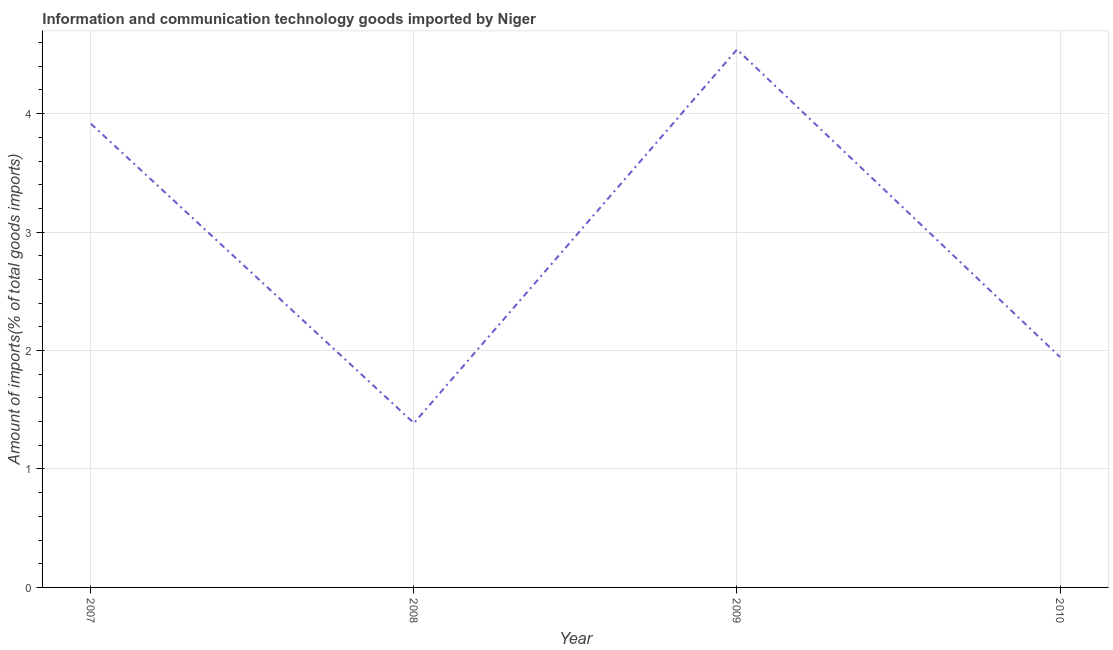What is the amount of ict goods imports in 2010?
Ensure brevity in your answer.  1.95. Across all years, what is the maximum amount of ict goods imports?
Your answer should be very brief. 4.54. Across all years, what is the minimum amount of ict goods imports?
Provide a short and direct response. 1.39. What is the sum of the amount of ict goods imports?
Provide a succinct answer. 11.79. What is the difference between the amount of ict goods imports in 2007 and 2008?
Make the answer very short. 2.53. What is the average amount of ict goods imports per year?
Your answer should be compact. 2.95. What is the median amount of ict goods imports?
Offer a terse response. 2.93. What is the ratio of the amount of ict goods imports in 2007 to that in 2008?
Give a very brief answer. 2.82. Is the amount of ict goods imports in 2007 less than that in 2008?
Ensure brevity in your answer.  No. Is the difference between the amount of ict goods imports in 2007 and 2010 greater than the difference between any two years?
Your response must be concise. No. What is the difference between the highest and the second highest amount of ict goods imports?
Offer a terse response. 0.63. Is the sum of the amount of ict goods imports in 2007 and 2008 greater than the maximum amount of ict goods imports across all years?
Offer a terse response. Yes. What is the difference between the highest and the lowest amount of ict goods imports?
Give a very brief answer. 3.15. In how many years, is the amount of ict goods imports greater than the average amount of ict goods imports taken over all years?
Your answer should be very brief. 2. Does the graph contain grids?
Your answer should be very brief. Yes. What is the title of the graph?
Your answer should be very brief. Information and communication technology goods imported by Niger. What is the label or title of the X-axis?
Your response must be concise. Year. What is the label or title of the Y-axis?
Provide a succinct answer. Amount of imports(% of total goods imports). What is the Amount of imports(% of total goods imports) in 2007?
Your answer should be very brief. 3.91. What is the Amount of imports(% of total goods imports) in 2008?
Offer a very short reply. 1.39. What is the Amount of imports(% of total goods imports) in 2009?
Offer a terse response. 4.54. What is the Amount of imports(% of total goods imports) of 2010?
Offer a terse response. 1.95. What is the difference between the Amount of imports(% of total goods imports) in 2007 and 2008?
Give a very brief answer. 2.53. What is the difference between the Amount of imports(% of total goods imports) in 2007 and 2009?
Ensure brevity in your answer.  -0.63. What is the difference between the Amount of imports(% of total goods imports) in 2007 and 2010?
Give a very brief answer. 1.97. What is the difference between the Amount of imports(% of total goods imports) in 2008 and 2009?
Your answer should be compact. -3.15. What is the difference between the Amount of imports(% of total goods imports) in 2008 and 2010?
Provide a succinct answer. -0.56. What is the difference between the Amount of imports(% of total goods imports) in 2009 and 2010?
Your response must be concise. 2.6. What is the ratio of the Amount of imports(% of total goods imports) in 2007 to that in 2008?
Ensure brevity in your answer.  2.82. What is the ratio of the Amount of imports(% of total goods imports) in 2007 to that in 2009?
Provide a succinct answer. 0.86. What is the ratio of the Amount of imports(% of total goods imports) in 2007 to that in 2010?
Your answer should be very brief. 2.01. What is the ratio of the Amount of imports(% of total goods imports) in 2008 to that in 2009?
Make the answer very short. 0.3. What is the ratio of the Amount of imports(% of total goods imports) in 2008 to that in 2010?
Your answer should be very brief. 0.71. What is the ratio of the Amount of imports(% of total goods imports) in 2009 to that in 2010?
Ensure brevity in your answer.  2.33. 